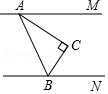First perform reasoning, then finally select the question from the choices in the following format: Answer: xxx.
Question: Given the figure with points A, B, C, M, and N, where line segment AM is parallel to line segment BN, and angle ACB is right angle while angle MAC measures 35 degrees, what is the degree measurement of angle CBN?
Choices:
A: 35°
B: 45°
C: 55°
D: 65° Make CF parallel to AM through point C. Since AM is parallel to BN, AM is also parallel to CF and BN. Therefore, angle MAC is equal to angle ACF, and angle CBN is equal to angle FCB. Since angle ACB is 90 degrees and angle MAC is 35 degrees, angle CBN is equal to angle FCB is equal to angle ACB minus angle ACF, which is equal to angle ACB minus angle MAC, which is equal to 90 degrees minus 35 degrees, which is equal to 55 degrees. Therefore, the correct answer is C.
Answer:C 